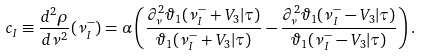<formula> <loc_0><loc_0><loc_500><loc_500>c _ { I } \equiv \frac { d ^ { 2 } \rho } { d \nu ^ { 2 } } ( \nu _ { I } ^ { - } ) = \alpha \left ( \frac { \partial ^ { 2 } _ { \nu } \vartheta _ { 1 } ( \nu _ { I } ^ { - } + V _ { 3 } | \tau ) } { \vartheta _ { 1 } ( \nu _ { I } ^ { - } + V _ { 3 } | \tau ) } - \frac { \partial ^ { 2 } _ { \nu } \vartheta _ { 1 } ( \nu _ { I } ^ { - } - V _ { 3 } | \tau ) } { \vartheta _ { 1 } ( \nu _ { I } ^ { - } - V _ { 3 } | \tau ) } \right ) .</formula> 